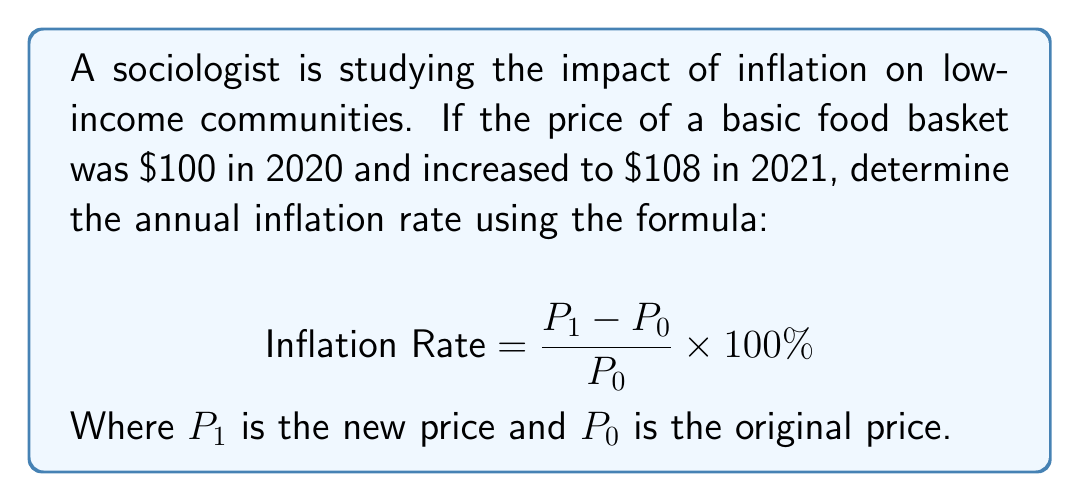Provide a solution to this math problem. To solve this problem, we'll use the given inflation rate formula and plug in the known values:

$P_0 = 100$ (original price in 2020)
$P_1 = 108$ (new price in 2021)

Let's substitute these values into the equation:

$$ \text{Inflation Rate} = \frac{P_1 - P_0}{P_0} \times 100\% $$

$$ \text{Inflation Rate} = \frac{108 - 100}{100} \times 100\% $$

$$ \text{Inflation Rate} = \frac{8}{100} \times 100\% $$

$$ \text{Inflation Rate} = 0.08 \times 100\% $$

$$ \text{Inflation Rate} = 8\% $$

This means that the annual inflation rate from 2020 to 2021 for the basic food basket was 8%.

Understanding this rate is crucial for sociologists studying socio-economic implications, as it directly affects the purchasing power and quality of life for low-income communities.
Answer: 8% 